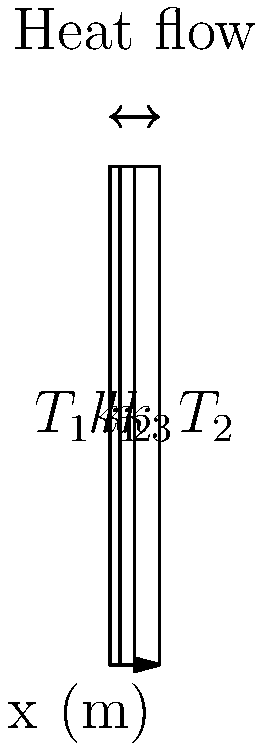A composite wall consists of three layers with thicknesses of 2 cm, 3 cm, and 5 cm, respectively. The thermal conductivities of these layers are $k_1 = 0.5$ W/(m·K), $k_2 = 1.2$ W/(m·K), and $k_3 = 0.8$ W/(m·K). If the temperature difference across the wall is 100°C, calculate the rate of heat transfer per unit area through the wall. To solve this problem, we'll use Fourier's law of heat conduction and the concept of thermal resistance in series. Let's proceed step by step:

1) The heat transfer rate per unit area (q) is given by:
   $$ q = \frac{\Delta T}{R_{total}} $$
   where $\Delta T$ is the temperature difference and $R_{total}$ is the total thermal resistance.

2) For materials in series, the total thermal resistance is the sum of individual resistances:
   $$ R_{total} = R_1 + R_2 + R_3 $$

3) The thermal resistance for each layer is given by:
   $$ R = \frac{L}{k} $$
   where L is the thickness and k is the thermal conductivity.

4) Calculate the thermal resistance for each layer:
   $$ R_1 = \frac{0.02}{0.5} = 0.04 \text{ m²·K/W} $$
   $$ R_2 = \frac{0.03}{1.2} = 0.025 \text{ m²·K/W} $$
   $$ R_3 = \frac{0.05}{0.8} = 0.0625 \text{ m²·K/W} $$

5) Calculate the total thermal resistance:
   $$ R_{total} = 0.04 + 0.025 + 0.0625 = 0.1275 \text{ m²·K/W} $$

6) Now, we can calculate the heat transfer rate per unit area:
   $$ q = \frac{\Delta T}{R_{total}} = \frac{100}{0.1275} = 784.31 \text{ W/m²} $$
Answer: 784.31 W/m² 